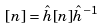<formula> <loc_0><loc_0><loc_500><loc_500>[ n ] = \hat { h } [ n ] \hat { h } ^ { - 1 }</formula> 